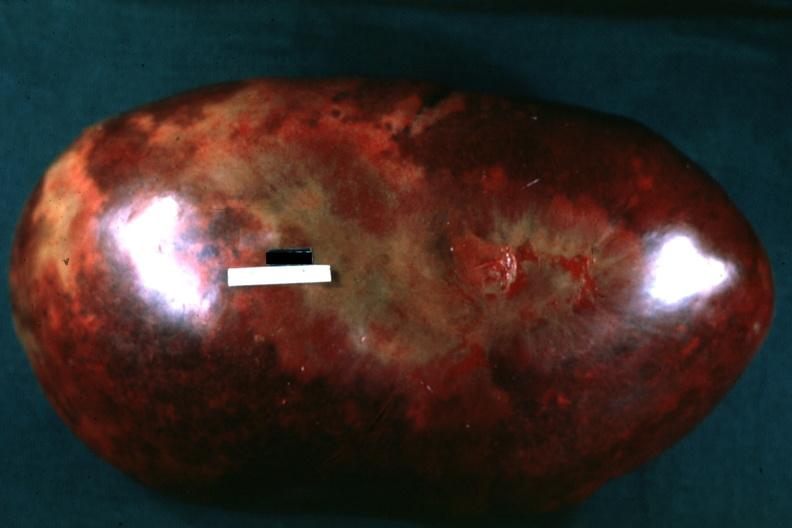what does this image show?
Answer the question using a single word or phrase. Massively enlarged spleen with large infarcts seen from capsule 